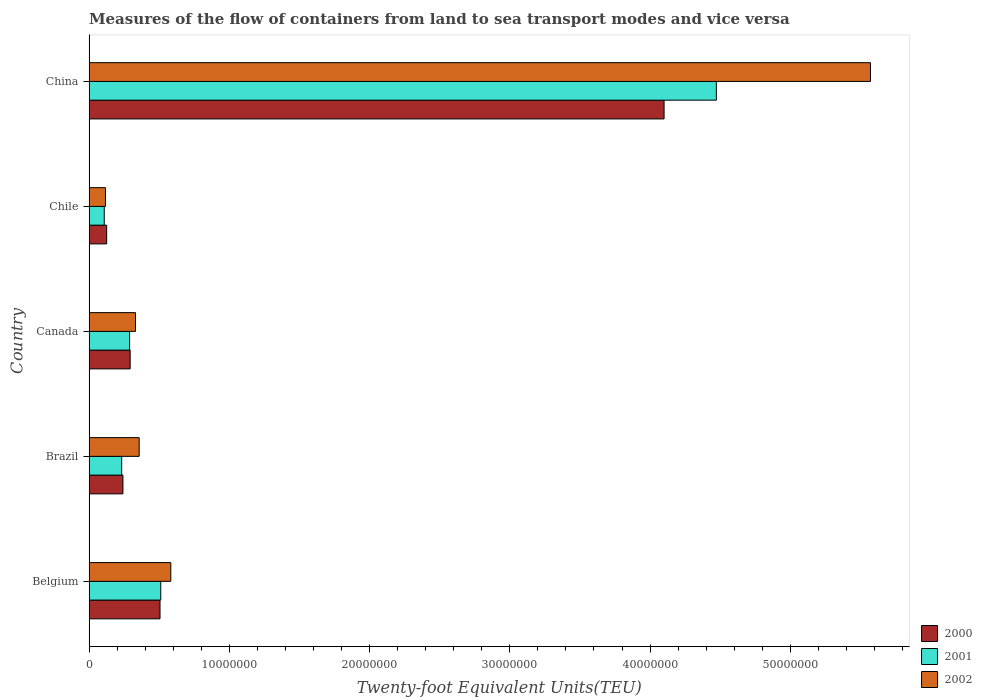How many different coloured bars are there?
Offer a terse response. 3. Are the number of bars on each tick of the Y-axis equal?
Your answer should be compact. Yes. How many bars are there on the 4th tick from the bottom?
Give a very brief answer. 3. What is the label of the 5th group of bars from the top?
Provide a succinct answer. Belgium. In how many cases, is the number of bars for a given country not equal to the number of legend labels?
Provide a succinct answer. 0. What is the container port traffic in 2001 in Belgium?
Provide a short and direct response. 5.11e+06. Across all countries, what is the maximum container port traffic in 2000?
Ensure brevity in your answer.  4.10e+07. Across all countries, what is the minimum container port traffic in 2002?
Offer a terse response. 1.17e+06. In which country was the container port traffic in 2000 minimum?
Your answer should be very brief. Chile. What is the total container port traffic in 2002 in the graph?
Your answer should be very brief. 6.96e+07. What is the difference between the container port traffic in 2000 in Belgium and that in China?
Your answer should be compact. -3.59e+07. What is the difference between the container port traffic in 2001 in China and the container port traffic in 2002 in Canada?
Ensure brevity in your answer.  4.14e+07. What is the average container port traffic in 2000 per country?
Provide a short and direct response. 1.05e+07. What is the difference between the container port traffic in 2002 and container port traffic in 2000 in Chile?
Your answer should be very brief. -8.53e+04. What is the ratio of the container port traffic in 2002 in Canada to that in China?
Ensure brevity in your answer.  0.06. Is the container port traffic in 2000 in Canada less than that in Chile?
Ensure brevity in your answer.  No. What is the difference between the highest and the second highest container port traffic in 2002?
Provide a short and direct response. 4.99e+07. What is the difference between the highest and the lowest container port traffic in 2002?
Your response must be concise. 5.45e+07. In how many countries, is the container port traffic in 2002 greater than the average container port traffic in 2002 taken over all countries?
Ensure brevity in your answer.  1. Is the sum of the container port traffic in 2000 in Brazil and Canada greater than the maximum container port traffic in 2001 across all countries?
Your answer should be very brief. No. Is it the case that in every country, the sum of the container port traffic in 2000 and container port traffic in 2002 is greater than the container port traffic in 2001?
Ensure brevity in your answer.  Yes. How many bars are there?
Provide a short and direct response. 15. Are all the bars in the graph horizontal?
Your answer should be very brief. Yes. How many countries are there in the graph?
Keep it short and to the point. 5. What is the difference between two consecutive major ticks on the X-axis?
Your answer should be very brief. 1.00e+07. Where does the legend appear in the graph?
Keep it short and to the point. Bottom right. How many legend labels are there?
Your answer should be very brief. 3. How are the legend labels stacked?
Provide a succinct answer. Vertical. What is the title of the graph?
Make the answer very short. Measures of the flow of containers from land to sea transport modes and vice versa. Does "2013" appear as one of the legend labels in the graph?
Make the answer very short. No. What is the label or title of the X-axis?
Ensure brevity in your answer.  Twenty-foot Equivalent Units(TEU). What is the label or title of the Y-axis?
Make the answer very short. Country. What is the Twenty-foot Equivalent Units(TEU) in 2000 in Belgium?
Keep it short and to the point. 5.06e+06. What is the Twenty-foot Equivalent Units(TEU) in 2001 in Belgium?
Your response must be concise. 5.11e+06. What is the Twenty-foot Equivalent Units(TEU) of 2002 in Belgium?
Provide a succinct answer. 5.83e+06. What is the Twenty-foot Equivalent Units(TEU) of 2000 in Brazil?
Provide a short and direct response. 2.41e+06. What is the Twenty-foot Equivalent Units(TEU) of 2001 in Brazil?
Keep it short and to the point. 2.32e+06. What is the Twenty-foot Equivalent Units(TEU) of 2002 in Brazil?
Keep it short and to the point. 3.57e+06. What is the Twenty-foot Equivalent Units(TEU) of 2000 in Canada?
Offer a very short reply. 2.93e+06. What is the Twenty-foot Equivalent Units(TEU) in 2001 in Canada?
Your answer should be very brief. 2.89e+06. What is the Twenty-foot Equivalent Units(TEU) in 2002 in Canada?
Provide a succinct answer. 3.31e+06. What is the Twenty-foot Equivalent Units(TEU) in 2000 in Chile?
Give a very brief answer. 1.25e+06. What is the Twenty-foot Equivalent Units(TEU) of 2001 in Chile?
Give a very brief answer. 1.08e+06. What is the Twenty-foot Equivalent Units(TEU) of 2002 in Chile?
Make the answer very short. 1.17e+06. What is the Twenty-foot Equivalent Units(TEU) of 2000 in China?
Your response must be concise. 4.10e+07. What is the Twenty-foot Equivalent Units(TEU) in 2001 in China?
Your response must be concise. 4.47e+07. What is the Twenty-foot Equivalent Units(TEU) of 2002 in China?
Ensure brevity in your answer.  5.57e+07. Across all countries, what is the maximum Twenty-foot Equivalent Units(TEU) of 2000?
Provide a short and direct response. 4.10e+07. Across all countries, what is the maximum Twenty-foot Equivalent Units(TEU) of 2001?
Keep it short and to the point. 4.47e+07. Across all countries, what is the maximum Twenty-foot Equivalent Units(TEU) of 2002?
Offer a terse response. 5.57e+07. Across all countries, what is the minimum Twenty-foot Equivalent Units(TEU) in 2000?
Keep it short and to the point. 1.25e+06. Across all countries, what is the minimum Twenty-foot Equivalent Units(TEU) in 2001?
Your answer should be very brief. 1.08e+06. Across all countries, what is the minimum Twenty-foot Equivalent Units(TEU) in 2002?
Make the answer very short. 1.17e+06. What is the total Twenty-foot Equivalent Units(TEU) of 2000 in the graph?
Your answer should be compact. 5.27e+07. What is the total Twenty-foot Equivalent Units(TEU) in 2001 in the graph?
Give a very brief answer. 5.61e+07. What is the total Twenty-foot Equivalent Units(TEU) in 2002 in the graph?
Your answer should be very brief. 6.96e+07. What is the difference between the Twenty-foot Equivalent Units(TEU) of 2000 in Belgium and that in Brazil?
Provide a succinct answer. 2.64e+06. What is the difference between the Twenty-foot Equivalent Units(TEU) in 2001 in Belgium and that in Brazil?
Provide a succinct answer. 2.79e+06. What is the difference between the Twenty-foot Equivalent Units(TEU) of 2002 in Belgium and that in Brazil?
Provide a succinct answer. 2.26e+06. What is the difference between the Twenty-foot Equivalent Units(TEU) of 2000 in Belgium and that in Canada?
Offer a very short reply. 2.13e+06. What is the difference between the Twenty-foot Equivalent Units(TEU) in 2001 in Belgium and that in Canada?
Ensure brevity in your answer.  2.22e+06. What is the difference between the Twenty-foot Equivalent Units(TEU) of 2002 in Belgium and that in Canada?
Ensure brevity in your answer.  2.52e+06. What is the difference between the Twenty-foot Equivalent Units(TEU) of 2000 in Belgium and that in Chile?
Keep it short and to the point. 3.80e+06. What is the difference between the Twenty-foot Equivalent Units(TEU) in 2001 in Belgium and that in Chile?
Offer a very short reply. 4.03e+06. What is the difference between the Twenty-foot Equivalent Units(TEU) of 2002 in Belgium and that in Chile?
Your answer should be compact. 4.66e+06. What is the difference between the Twenty-foot Equivalent Units(TEU) of 2000 in Belgium and that in China?
Your answer should be very brief. -3.59e+07. What is the difference between the Twenty-foot Equivalent Units(TEU) in 2001 in Belgium and that in China?
Provide a succinct answer. -3.96e+07. What is the difference between the Twenty-foot Equivalent Units(TEU) of 2002 in Belgium and that in China?
Keep it short and to the point. -4.99e+07. What is the difference between the Twenty-foot Equivalent Units(TEU) in 2000 in Brazil and that in Canada?
Offer a terse response. -5.15e+05. What is the difference between the Twenty-foot Equivalent Units(TEU) of 2001 in Brazil and that in Canada?
Give a very brief answer. -5.67e+05. What is the difference between the Twenty-foot Equivalent Units(TEU) of 2002 in Brazil and that in Canada?
Make the answer very short. 2.63e+05. What is the difference between the Twenty-foot Equivalent Units(TEU) in 2000 in Brazil and that in Chile?
Your response must be concise. 1.16e+06. What is the difference between the Twenty-foot Equivalent Units(TEU) of 2001 in Brazil and that in Chile?
Ensure brevity in your answer.  1.24e+06. What is the difference between the Twenty-foot Equivalent Units(TEU) in 2002 in Brazil and that in Chile?
Provide a short and direct response. 2.40e+06. What is the difference between the Twenty-foot Equivalent Units(TEU) in 2000 in Brazil and that in China?
Your answer should be compact. -3.86e+07. What is the difference between the Twenty-foot Equivalent Units(TEU) of 2001 in Brazil and that in China?
Offer a very short reply. -4.24e+07. What is the difference between the Twenty-foot Equivalent Units(TEU) of 2002 in Brazil and that in China?
Provide a short and direct response. -5.21e+07. What is the difference between the Twenty-foot Equivalent Units(TEU) in 2000 in Canada and that in Chile?
Offer a terse response. 1.67e+06. What is the difference between the Twenty-foot Equivalent Units(TEU) in 2001 in Canada and that in Chile?
Your answer should be compact. 1.81e+06. What is the difference between the Twenty-foot Equivalent Units(TEU) of 2002 in Canada and that in Chile?
Provide a succinct answer. 2.14e+06. What is the difference between the Twenty-foot Equivalent Units(TEU) in 2000 in Canada and that in China?
Offer a terse response. -3.81e+07. What is the difference between the Twenty-foot Equivalent Units(TEU) of 2001 in Canada and that in China?
Provide a succinct answer. -4.18e+07. What is the difference between the Twenty-foot Equivalent Units(TEU) in 2002 in Canada and that in China?
Your answer should be compact. -5.24e+07. What is the difference between the Twenty-foot Equivalent Units(TEU) of 2000 in Chile and that in China?
Make the answer very short. -3.97e+07. What is the difference between the Twenty-foot Equivalent Units(TEU) of 2001 in Chile and that in China?
Ensure brevity in your answer.  -4.36e+07. What is the difference between the Twenty-foot Equivalent Units(TEU) of 2002 in Chile and that in China?
Your response must be concise. -5.45e+07. What is the difference between the Twenty-foot Equivalent Units(TEU) in 2000 in Belgium and the Twenty-foot Equivalent Units(TEU) in 2001 in Brazil?
Make the answer very short. 2.73e+06. What is the difference between the Twenty-foot Equivalent Units(TEU) of 2000 in Belgium and the Twenty-foot Equivalent Units(TEU) of 2002 in Brazil?
Your answer should be very brief. 1.49e+06. What is the difference between the Twenty-foot Equivalent Units(TEU) in 2001 in Belgium and the Twenty-foot Equivalent Units(TEU) in 2002 in Brazil?
Offer a very short reply. 1.54e+06. What is the difference between the Twenty-foot Equivalent Units(TEU) in 2000 in Belgium and the Twenty-foot Equivalent Units(TEU) in 2001 in Canada?
Your answer should be very brief. 2.17e+06. What is the difference between the Twenty-foot Equivalent Units(TEU) of 2000 in Belgium and the Twenty-foot Equivalent Units(TEU) of 2002 in Canada?
Offer a terse response. 1.75e+06. What is the difference between the Twenty-foot Equivalent Units(TEU) in 2001 in Belgium and the Twenty-foot Equivalent Units(TEU) in 2002 in Canada?
Make the answer very short. 1.80e+06. What is the difference between the Twenty-foot Equivalent Units(TEU) in 2000 in Belgium and the Twenty-foot Equivalent Units(TEU) in 2001 in Chile?
Give a very brief answer. 3.98e+06. What is the difference between the Twenty-foot Equivalent Units(TEU) in 2000 in Belgium and the Twenty-foot Equivalent Units(TEU) in 2002 in Chile?
Your response must be concise. 3.89e+06. What is the difference between the Twenty-foot Equivalent Units(TEU) in 2001 in Belgium and the Twenty-foot Equivalent Units(TEU) in 2002 in Chile?
Ensure brevity in your answer.  3.94e+06. What is the difference between the Twenty-foot Equivalent Units(TEU) in 2000 in Belgium and the Twenty-foot Equivalent Units(TEU) in 2001 in China?
Your response must be concise. -3.97e+07. What is the difference between the Twenty-foot Equivalent Units(TEU) of 2000 in Belgium and the Twenty-foot Equivalent Units(TEU) of 2002 in China?
Provide a succinct answer. -5.07e+07. What is the difference between the Twenty-foot Equivalent Units(TEU) in 2001 in Belgium and the Twenty-foot Equivalent Units(TEU) in 2002 in China?
Provide a succinct answer. -5.06e+07. What is the difference between the Twenty-foot Equivalent Units(TEU) of 2000 in Brazil and the Twenty-foot Equivalent Units(TEU) of 2001 in Canada?
Offer a terse response. -4.77e+05. What is the difference between the Twenty-foot Equivalent Units(TEU) of 2000 in Brazil and the Twenty-foot Equivalent Units(TEU) of 2002 in Canada?
Offer a terse response. -8.94e+05. What is the difference between the Twenty-foot Equivalent Units(TEU) in 2001 in Brazil and the Twenty-foot Equivalent Units(TEU) in 2002 in Canada?
Provide a succinct answer. -9.84e+05. What is the difference between the Twenty-foot Equivalent Units(TEU) in 2000 in Brazil and the Twenty-foot Equivalent Units(TEU) in 2001 in Chile?
Provide a succinct answer. 1.33e+06. What is the difference between the Twenty-foot Equivalent Units(TEU) in 2000 in Brazil and the Twenty-foot Equivalent Units(TEU) in 2002 in Chile?
Provide a succinct answer. 1.25e+06. What is the difference between the Twenty-foot Equivalent Units(TEU) of 2001 in Brazil and the Twenty-foot Equivalent Units(TEU) of 2002 in Chile?
Make the answer very short. 1.16e+06. What is the difference between the Twenty-foot Equivalent Units(TEU) of 2000 in Brazil and the Twenty-foot Equivalent Units(TEU) of 2001 in China?
Offer a very short reply. -4.23e+07. What is the difference between the Twenty-foot Equivalent Units(TEU) in 2000 in Brazil and the Twenty-foot Equivalent Units(TEU) in 2002 in China?
Keep it short and to the point. -5.33e+07. What is the difference between the Twenty-foot Equivalent Units(TEU) of 2001 in Brazil and the Twenty-foot Equivalent Units(TEU) of 2002 in China?
Make the answer very short. -5.34e+07. What is the difference between the Twenty-foot Equivalent Units(TEU) of 2000 in Canada and the Twenty-foot Equivalent Units(TEU) of 2001 in Chile?
Your response must be concise. 1.85e+06. What is the difference between the Twenty-foot Equivalent Units(TEU) in 2000 in Canada and the Twenty-foot Equivalent Units(TEU) in 2002 in Chile?
Offer a very short reply. 1.76e+06. What is the difference between the Twenty-foot Equivalent Units(TEU) of 2001 in Canada and the Twenty-foot Equivalent Units(TEU) of 2002 in Chile?
Keep it short and to the point. 1.72e+06. What is the difference between the Twenty-foot Equivalent Units(TEU) in 2000 in Canada and the Twenty-foot Equivalent Units(TEU) in 2001 in China?
Provide a succinct answer. -4.18e+07. What is the difference between the Twenty-foot Equivalent Units(TEU) in 2000 in Canada and the Twenty-foot Equivalent Units(TEU) in 2002 in China?
Provide a succinct answer. -5.28e+07. What is the difference between the Twenty-foot Equivalent Units(TEU) in 2001 in Canada and the Twenty-foot Equivalent Units(TEU) in 2002 in China?
Ensure brevity in your answer.  -5.28e+07. What is the difference between the Twenty-foot Equivalent Units(TEU) in 2000 in Chile and the Twenty-foot Equivalent Units(TEU) in 2001 in China?
Your response must be concise. -4.35e+07. What is the difference between the Twenty-foot Equivalent Units(TEU) in 2000 in Chile and the Twenty-foot Equivalent Units(TEU) in 2002 in China?
Your answer should be compact. -5.45e+07. What is the difference between the Twenty-foot Equivalent Units(TEU) of 2001 in Chile and the Twenty-foot Equivalent Units(TEU) of 2002 in China?
Offer a very short reply. -5.46e+07. What is the average Twenty-foot Equivalent Units(TEU) in 2000 per country?
Ensure brevity in your answer.  1.05e+07. What is the average Twenty-foot Equivalent Units(TEU) of 2001 per country?
Your answer should be compact. 1.12e+07. What is the average Twenty-foot Equivalent Units(TEU) of 2002 per country?
Make the answer very short. 1.39e+07. What is the difference between the Twenty-foot Equivalent Units(TEU) of 2000 and Twenty-foot Equivalent Units(TEU) of 2001 in Belgium?
Offer a terse response. -5.21e+04. What is the difference between the Twenty-foot Equivalent Units(TEU) in 2000 and Twenty-foot Equivalent Units(TEU) in 2002 in Belgium?
Keep it short and to the point. -7.68e+05. What is the difference between the Twenty-foot Equivalent Units(TEU) of 2001 and Twenty-foot Equivalent Units(TEU) of 2002 in Belgium?
Make the answer very short. -7.16e+05. What is the difference between the Twenty-foot Equivalent Units(TEU) in 2000 and Twenty-foot Equivalent Units(TEU) in 2001 in Brazil?
Offer a very short reply. 8.93e+04. What is the difference between the Twenty-foot Equivalent Units(TEU) of 2000 and Twenty-foot Equivalent Units(TEU) of 2002 in Brazil?
Keep it short and to the point. -1.16e+06. What is the difference between the Twenty-foot Equivalent Units(TEU) of 2001 and Twenty-foot Equivalent Units(TEU) of 2002 in Brazil?
Your answer should be compact. -1.25e+06. What is the difference between the Twenty-foot Equivalent Units(TEU) in 2000 and Twenty-foot Equivalent Units(TEU) in 2001 in Canada?
Keep it short and to the point. 3.76e+04. What is the difference between the Twenty-foot Equivalent Units(TEU) in 2000 and Twenty-foot Equivalent Units(TEU) in 2002 in Canada?
Make the answer very short. -3.79e+05. What is the difference between the Twenty-foot Equivalent Units(TEU) of 2001 and Twenty-foot Equivalent Units(TEU) of 2002 in Canada?
Keep it short and to the point. -4.17e+05. What is the difference between the Twenty-foot Equivalent Units(TEU) of 2000 and Twenty-foot Equivalent Units(TEU) of 2001 in Chile?
Give a very brief answer. 1.73e+05. What is the difference between the Twenty-foot Equivalent Units(TEU) in 2000 and Twenty-foot Equivalent Units(TEU) in 2002 in Chile?
Your response must be concise. 8.53e+04. What is the difference between the Twenty-foot Equivalent Units(TEU) in 2001 and Twenty-foot Equivalent Units(TEU) in 2002 in Chile?
Provide a succinct answer. -8.73e+04. What is the difference between the Twenty-foot Equivalent Units(TEU) in 2000 and Twenty-foot Equivalent Units(TEU) in 2001 in China?
Your answer should be very brief. -3.73e+06. What is the difference between the Twenty-foot Equivalent Units(TEU) in 2000 and Twenty-foot Equivalent Units(TEU) in 2002 in China?
Keep it short and to the point. -1.47e+07. What is the difference between the Twenty-foot Equivalent Units(TEU) in 2001 and Twenty-foot Equivalent Units(TEU) in 2002 in China?
Offer a very short reply. -1.10e+07. What is the ratio of the Twenty-foot Equivalent Units(TEU) in 2000 in Belgium to that in Brazil?
Offer a terse response. 2.1. What is the ratio of the Twenty-foot Equivalent Units(TEU) in 2001 in Belgium to that in Brazil?
Your answer should be very brief. 2.2. What is the ratio of the Twenty-foot Equivalent Units(TEU) of 2002 in Belgium to that in Brazil?
Make the answer very short. 1.63. What is the ratio of the Twenty-foot Equivalent Units(TEU) of 2000 in Belgium to that in Canada?
Provide a short and direct response. 1.73. What is the ratio of the Twenty-foot Equivalent Units(TEU) of 2001 in Belgium to that in Canada?
Offer a very short reply. 1.77. What is the ratio of the Twenty-foot Equivalent Units(TEU) of 2002 in Belgium to that in Canada?
Keep it short and to the point. 1.76. What is the ratio of the Twenty-foot Equivalent Units(TEU) in 2000 in Belgium to that in Chile?
Keep it short and to the point. 4.04. What is the ratio of the Twenty-foot Equivalent Units(TEU) in 2001 in Belgium to that in Chile?
Your response must be concise. 4.73. What is the ratio of the Twenty-foot Equivalent Units(TEU) of 2002 in Belgium to that in Chile?
Provide a short and direct response. 4.99. What is the ratio of the Twenty-foot Equivalent Units(TEU) in 2000 in Belgium to that in China?
Keep it short and to the point. 0.12. What is the ratio of the Twenty-foot Equivalent Units(TEU) of 2001 in Belgium to that in China?
Give a very brief answer. 0.11. What is the ratio of the Twenty-foot Equivalent Units(TEU) of 2002 in Belgium to that in China?
Your answer should be compact. 0.1. What is the ratio of the Twenty-foot Equivalent Units(TEU) of 2000 in Brazil to that in Canada?
Offer a terse response. 0.82. What is the ratio of the Twenty-foot Equivalent Units(TEU) in 2001 in Brazil to that in Canada?
Your answer should be compact. 0.8. What is the ratio of the Twenty-foot Equivalent Units(TEU) in 2002 in Brazil to that in Canada?
Offer a terse response. 1.08. What is the ratio of the Twenty-foot Equivalent Units(TEU) of 2000 in Brazil to that in Chile?
Give a very brief answer. 1.93. What is the ratio of the Twenty-foot Equivalent Units(TEU) in 2001 in Brazil to that in Chile?
Your response must be concise. 2.15. What is the ratio of the Twenty-foot Equivalent Units(TEU) of 2002 in Brazil to that in Chile?
Your answer should be very brief. 3.06. What is the ratio of the Twenty-foot Equivalent Units(TEU) in 2000 in Brazil to that in China?
Your answer should be compact. 0.06. What is the ratio of the Twenty-foot Equivalent Units(TEU) in 2001 in Brazil to that in China?
Give a very brief answer. 0.05. What is the ratio of the Twenty-foot Equivalent Units(TEU) in 2002 in Brazil to that in China?
Keep it short and to the point. 0.06. What is the ratio of the Twenty-foot Equivalent Units(TEU) of 2000 in Canada to that in Chile?
Ensure brevity in your answer.  2.34. What is the ratio of the Twenty-foot Equivalent Units(TEU) of 2001 in Canada to that in Chile?
Keep it short and to the point. 2.67. What is the ratio of the Twenty-foot Equivalent Units(TEU) in 2002 in Canada to that in Chile?
Your answer should be compact. 2.83. What is the ratio of the Twenty-foot Equivalent Units(TEU) in 2000 in Canada to that in China?
Offer a terse response. 0.07. What is the ratio of the Twenty-foot Equivalent Units(TEU) of 2001 in Canada to that in China?
Your response must be concise. 0.06. What is the ratio of the Twenty-foot Equivalent Units(TEU) in 2002 in Canada to that in China?
Make the answer very short. 0.06. What is the ratio of the Twenty-foot Equivalent Units(TEU) of 2000 in Chile to that in China?
Keep it short and to the point. 0.03. What is the ratio of the Twenty-foot Equivalent Units(TEU) in 2001 in Chile to that in China?
Ensure brevity in your answer.  0.02. What is the ratio of the Twenty-foot Equivalent Units(TEU) in 2002 in Chile to that in China?
Your answer should be compact. 0.02. What is the difference between the highest and the second highest Twenty-foot Equivalent Units(TEU) in 2000?
Offer a very short reply. 3.59e+07. What is the difference between the highest and the second highest Twenty-foot Equivalent Units(TEU) of 2001?
Provide a short and direct response. 3.96e+07. What is the difference between the highest and the second highest Twenty-foot Equivalent Units(TEU) in 2002?
Provide a short and direct response. 4.99e+07. What is the difference between the highest and the lowest Twenty-foot Equivalent Units(TEU) of 2000?
Keep it short and to the point. 3.97e+07. What is the difference between the highest and the lowest Twenty-foot Equivalent Units(TEU) in 2001?
Provide a succinct answer. 4.36e+07. What is the difference between the highest and the lowest Twenty-foot Equivalent Units(TEU) of 2002?
Offer a terse response. 5.45e+07. 